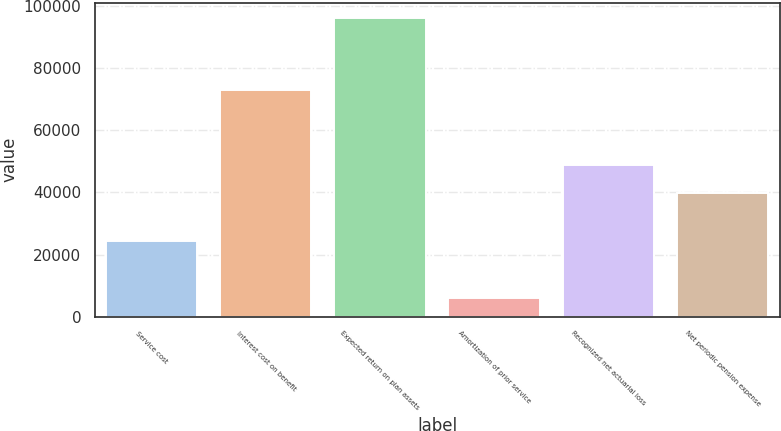<chart> <loc_0><loc_0><loc_500><loc_500><bar_chart><fcel>Service cost<fcel>Interest cost on benefit<fcel>Expected return on plan assets<fcel>Amortization of prior service<fcel>Recognized net actuarial loss<fcel>Net periodic pension expense<nl><fcel>24372<fcel>72731<fcel>96155<fcel>6005<fcel>48783<fcel>39768<nl></chart> 